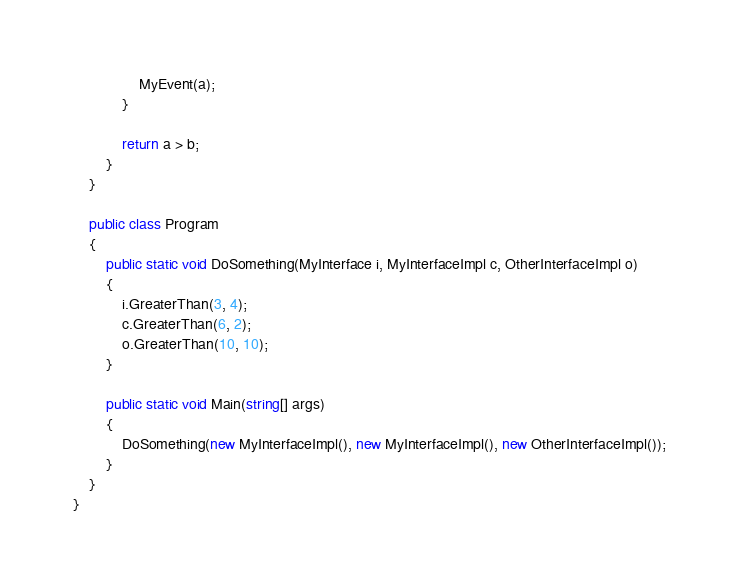<code> <loc_0><loc_0><loc_500><loc_500><_C#_>				MyEvent(a);
			}
            
            return a > b;
        }   
    }

    public class Program
    {
        public static void DoSomething(MyInterface i, MyInterfaceImpl c, OtherInterfaceImpl o)
        {
            i.GreaterThan(3, 4);
            c.GreaterThan(6, 2);
            o.GreaterThan(10, 10);
        }
        
        public static void Main(string[] args)
        {
            DoSomething(new MyInterfaceImpl(), new MyInterfaceImpl(), new OtherInterfaceImpl());
        }
    }
}
</code> 